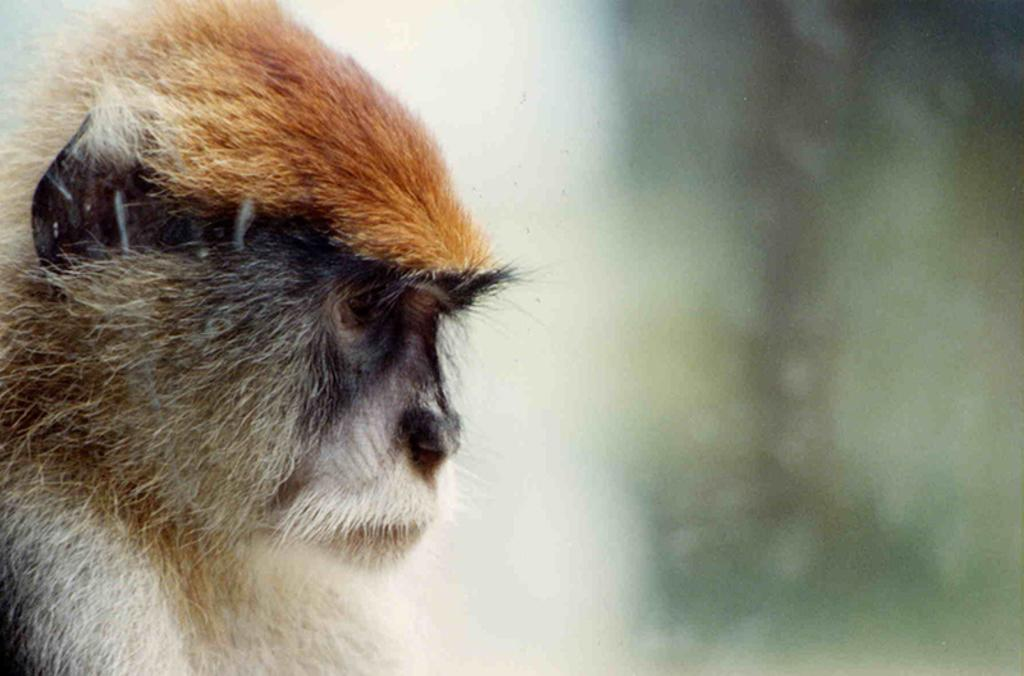What animal is present in the image? There is a monkey in the image. Can you describe the background of the image? The background of the image is blurred. What type of pickle is the monkey holding in the image? There is no pickle present in the image, and the monkey is not holding anything. 